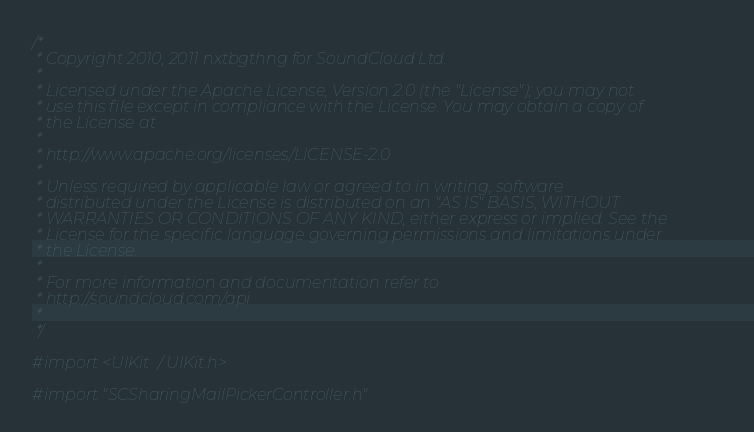<code> <loc_0><loc_0><loc_500><loc_500><_C_>/*
 * Copyright 2010, 2011 nxtbgthng for SoundCloud Ltd.
 * 
 * Licensed under the Apache License, Version 2.0 (the "License"); you may not
 * use this file except in compliance with the License. You may obtain a copy of
 * the License at
 * 
 * http://www.apache.org/licenses/LICENSE-2.0
 * 
 * Unless required by applicable law or agreed to in writing, software
 * distributed under the License is distributed on an "AS IS" BASIS, WITHOUT
 * WARRANTIES OR CONDITIONS OF ANY KIND, either express or implied. See the
 * License for the specific language governing permissions and limitations under
 * the License.
 *
 * For more information and documentation refer to
 * http://soundcloud.com/api
 * 
 */

#import <UIKit/UIKit.h>

#import "SCSharingMailPickerController.h"</code> 